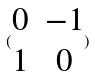Convert formula to latex. <formula><loc_0><loc_0><loc_500><loc_500>( \begin{matrix} 0 & - 1 \\ 1 & 0 \end{matrix} )</formula> 